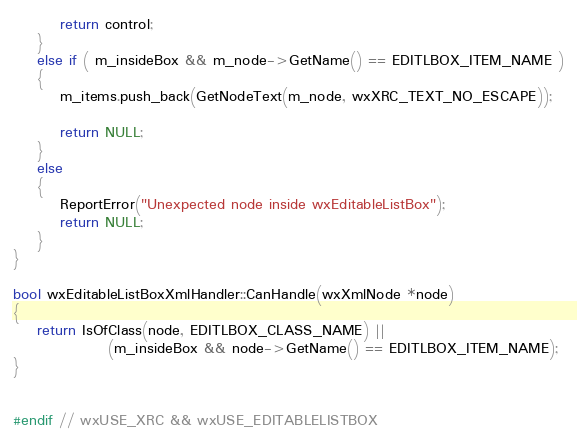<code> <loc_0><loc_0><loc_500><loc_500><_C++_>
        return control;
    }
    else if ( m_insideBox && m_node->GetName() == EDITLBOX_ITEM_NAME )
    {
        m_items.push_back(GetNodeText(m_node, wxXRC_TEXT_NO_ESCAPE));

        return NULL;
    }
    else
    {
        ReportError("Unexpected node inside wxEditableListBox");
        return NULL;
    }
}

bool wxEditableListBoxXmlHandler::CanHandle(wxXmlNode *node)
{
    return IsOfClass(node, EDITLBOX_CLASS_NAME) ||
                (m_insideBox && node->GetName() == EDITLBOX_ITEM_NAME);
}


#endif // wxUSE_XRC && wxUSE_EDITABLELISTBOX
</code> 